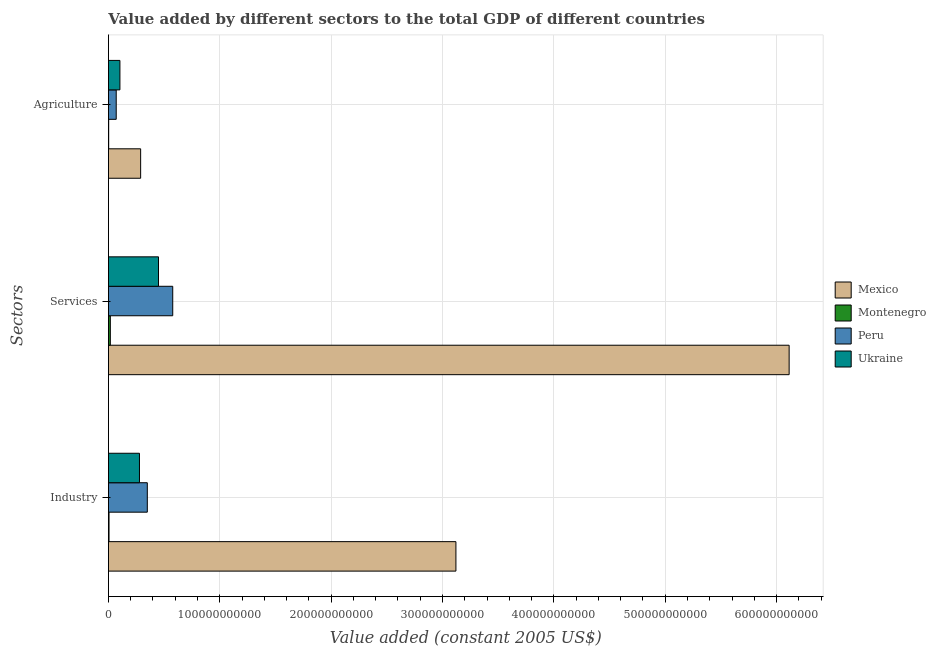How many different coloured bars are there?
Provide a succinct answer. 4. How many groups of bars are there?
Your response must be concise. 3. Are the number of bars per tick equal to the number of legend labels?
Provide a short and direct response. Yes. How many bars are there on the 3rd tick from the top?
Provide a short and direct response. 4. How many bars are there on the 2nd tick from the bottom?
Ensure brevity in your answer.  4. What is the label of the 1st group of bars from the top?
Give a very brief answer. Agriculture. What is the value added by industrial sector in Montenegro?
Your answer should be compact. 5.45e+08. Across all countries, what is the maximum value added by agricultural sector?
Give a very brief answer. 2.89e+1. Across all countries, what is the minimum value added by industrial sector?
Ensure brevity in your answer.  5.45e+08. In which country was the value added by services maximum?
Offer a terse response. Mexico. In which country was the value added by agricultural sector minimum?
Keep it short and to the point. Montenegro. What is the total value added by services in the graph?
Ensure brevity in your answer.  7.16e+11. What is the difference between the value added by industrial sector in Ukraine and that in Montenegro?
Provide a short and direct response. 2.73e+1. What is the difference between the value added by agricultural sector in Ukraine and the value added by industrial sector in Mexico?
Give a very brief answer. -3.02e+11. What is the average value added by agricultural sector per country?
Make the answer very short. 1.16e+1. What is the difference between the value added by services and value added by industrial sector in Mexico?
Offer a very short reply. 2.99e+11. In how many countries, is the value added by industrial sector greater than 120000000000 US$?
Offer a very short reply. 1. What is the ratio of the value added by services in Peru to that in Montenegro?
Give a very brief answer. 33.91. What is the difference between the highest and the second highest value added by agricultural sector?
Your answer should be very brief. 1.86e+1. What is the difference between the highest and the lowest value added by agricultural sector?
Your response must be concise. 2.87e+1. In how many countries, is the value added by agricultural sector greater than the average value added by agricultural sector taken over all countries?
Provide a succinct answer. 1. Is the sum of the value added by industrial sector in Montenegro and Mexico greater than the maximum value added by agricultural sector across all countries?
Your answer should be very brief. Yes. What does the 3rd bar from the top in Services represents?
Provide a short and direct response. Montenegro. What does the 2nd bar from the bottom in Agriculture represents?
Provide a succinct answer. Montenegro. How many countries are there in the graph?
Make the answer very short. 4. What is the difference between two consecutive major ticks on the X-axis?
Offer a terse response. 1.00e+11. Does the graph contain any zero values?
Provide a succinct answer. No. How are the legend labels stacked?
Provide a short and direct response. Vertical. What is the title of the graph?
Ensure brevity in your answer.  Value added by different sectors to the total GDP of different countries. Does "Antigua and Barbuda" appear as one of the legend labels in the graph?
Keep it short and to the point. No. What is the label or title of the X-axis?
Your answer should be compact. Value added (constant 2005 US$). What is the label or title of the Y-axis?
Ensure brevity in your answer.  Sectors. What is the Value added (constant 2005 US$) of Mexico in Industry?
Offer a very short reply. 3.12e+11. What is the Value added (constant 2005 US$) in Montenegro in Industry?
Provide a succinct answer. 5.45e+08. What is the Value added (constant 2005 US$) of Peru in Industry?
Your answer should be compact. 3.49e+1. What is the Value added (constant 2005 US$) in Ukraine in Industry?
Keep it short and to the point. 2.79e+1. What is the Value added (constant 2005 US$) in Mexico in Services?
Offer a very short reply. 6.11e+11. What is the Value added (constant 2005 US$) in Montenegro in Services?
Make the answer very short. 1.70e+09. What is the Value added (constant 2005 US$) in Peru in Services?
Your answer should be very brief. 5.77e+1. What is the Value added (constant 2005 US$) of Ukraine in Services?
Give a very brief answer. 4.50e+1. What is the Value added (constant 2005 US$) of Mexico in Agriculture?
Your answer should be very brief. 2.89e+1. What is the Value added (constant 2005 US$) of Montenegro in Agriculture?
Ensure brevity in your answer.  2.27e+08. What is the Value added (constant 2005 US$) of Peru in Agriculture?
Offer a very short reply. 6.99e+09. What is the Value added (constant 2005 US$) in Ukraine in Agriculture?
Keep it short and to the point. 1.03e+1. Across all Sectors, what is the maximum Value added (constant 2005 US$) in Mexico?
Make the answer very short. 6.11e+11. Across all Sectors, what is the maximum Value added (constant 2005 US$) in Montenegro?
Ensure brevity in your answer.  1.70e+09. Across all Sectors, what is the maximum Value added (constant 2005 US$) in Peru?
Ensure brevity in your answer.  5.77e+1. Across all Sectors, what is the maximum Value added (constant 2005 US$) of Ukraine?
Offer a terse response. 4.50e+1. Across all Sectors, what is the minimum Value added (constant 2005 US$) in Mexico?
Your answer should be very brief. 2.89e+1. Across all Sectors, what is the minimum Value added (constant 2005 US$) of Montenegro?
Offer a terse response. 2.27e+08. Across all Sectors, what is the minimum Value added (constant 2005 US$) in Peru?
Offer a terse response. 6.99e+09. Across all Sectors, what is the minimum Value added (constant 2005 US$) of Ukraine?
Your answer should be compact. 1.03e+1. What is the total Value added (constant 2005 US$) in Mexico in the graph?
Offer a terse response. 9.52e+11. What is the total Value added (constant 2005 US$) in Montenegro in the graph?
Keep it short and to the point. 2.47e+09. What is the total Value added (constant 2005 US$) of Peru in the graph?
Make the answer very short. 9.97e+1. What is the total Value added (constant 2005 US$) in Ukraine in the graph?
Make the answer very short. 8.31e+1. What is the difference between the Value added (constant 2005 US$) of Mexico in Industry and that in Services?
Your answer should be compact. -2.99e+11. What is the difference between the Value added (constant 2005 US$) in Montenegro in Industry and that in Services?
Your answer should be compact. -1.16e+09. What is the difference between the Value added (constant 2005 US$) in Peru in Industry and that in Services?
Ensure brevity in your answer.  -2.28e+1. What is the difference between the Value added (constant 2005 US$) in Ukraine in Industry and that in Services?
Offer a very short reply. -1.71e+1. What is the difference between the Value added (constant 2005 US$) in Mexico in Industry and that in Agriculture?
Give a very brief answer. 2.83e+11. What is the difference between the Value added (constant 2005 US$) in Montenegro in Industry and that in Agriculture?
Offer a terse response. 3.18e+08. What is the difference between the Value added (constant 2005 US$) of Peru in Industry and that in Agriculture?
Your answer should be very brief. 2.79e+1. What is the difference between the Value added (constant 2005 US$) of Ukraine in Industry and that in Agriculture?
Provide a short and direct response. 1.76e+1. What is the difference between the Value added (constant 2005 US$) of Mexico in Services and that in Agriculture?
Keep it short and to the point. 5.82e+11. What is the difference between the Value added (constant 2005 US$) in Montenegro in Services and that in Agriculture?
Provide a succinct answer. 1.48e+09. What is the difference between the Value added (constant 2005 US$) of Peru in Services and that in Agriculture?
Make the answer very short. 5.08e+1. What is the difference between the Value added (constant 2005 US$) in Ukraine in Services and that in Agriculture?
Your response must be concise. 3.46e+1. What is the difference between the Value added (constant 2005 US$) of Mexico in Industry and the Value added (constant 2005 US$) of Montenegro in Services?
Offer a very short reply. 3.10e+11. What is the difference between the Value added (constant 2005 US$) in Mexico in Industry and the Value added (constant 2005 US$) in Peru in Services?
Provide a succinct answer. 2.54e+11. What is the difference between the Value added (constant 2005 US$) of Mexico in Industry and the Value added (constant 2005 US$) of Ukraine in Services?
Your response must be concise. 2.67e+11. What is the difference between the Value added (constant 2005 US$) in Montenegro in Industry and the Value added (constant 2005 US$) in Peru in Services?
Provide a succinct answer. -5.72e+1. What is the difference between the Value added (constant 2005 US$) in Montenegro in Industry and the Value added (constant 2005 US$) in Ukraine in Services?
Your answer should be compact. -4.44e+1. What is the difference between the Value added (constant 2005 US$) in Peru in Industry and the Value added (constant 2005 US$) in Ukraine in Services?
Your answer should be very brief. -1.00e+1. What is the difference between the Value added (constant 2005 US$) in Mexico in Industry and the Value added (constant 2005 US$) in Montenegro in Agriculture?
Give a very brief answer. 3.12e+11. What is the difference between the Value added (constant 2005 US$) in Mexico in Industry and the Value added (constant 2005 US$) in Peru in Agriculture?
Ensure brevity in your answer.  3.05e+11. What is the difference between the Value added (constant 2005 US$) of Mexico in Industry and the Value added (constant 2005 US$) of Ukraine in Agriculture?
Make the answer very short. 3.02e+11. What is the difference between the Value added (constant 2005 US$) of Montenegro in Industry and the Value added (constant 2005 US$) of Peru in Agriculture?
Make the answer very short. -6.45e+09. What is the difference between the Value added (constant 2005 US$) in Montenegro in Industry and the Value added (constant 2005 US$) in Ukraine in Agriculture?
Your answer should be compact. -9.77e+09. What is the difference between the Value added (constant 2005 US$) in Peru in Industry and the Value added (constant 2005 US$) in Ukraine in Agriculture?
Ensure brevity in your answer.  2.46e+1. What is the difference between the Value added (constant 2005 US$) in Mexico in Services and the Value added (constant 2005 US$) in Montenegro in Agriculture?
Offer a very short reply. 6.11e+11. What is the difference between the Value added (constant 2005 US$) in Mexico in Services and the Value added (constant 2005 US$) in Peru in Agriculture?
Offer a terse response. 6.04e+11. What is the difference between the Value added (constant 2005 US$) in Mexico in Services and the Value added (constant 2005 US$) in Ukraine in Agriculture?
Make the answer very short. 6.01e+11. What is the difference between the Value added (constant 2005 US$) of Montenegro in Services and the Value added (constant 2005 US$) of Peru in Agriculture?
Offer a very short reply. -5.29e+09. What is the difference between the Value added (constant 2005 US$) in Montenegro in Services and the Value added (constant 2005 US$) in Ukraine in Agriculture?
Your answer should be compact. -8.61e+09. What is the difference between the Value added (constant 2005 US$) of Peru in Services and the Value added (constant 2005 US$) of Ukraine in Agriculture?
Provide a short and direct response. 4.74e+1. What is the average Value added (constant 2005 US$) in Mexico per Sectors?
Offer a very short reply. 3.17e+11. What is the average Value added (constant 2005 US$) in Montenegro per Sectors?
Ensure brevity in your answer.  8.25e+08. What is the average Value added (constant 2005 US$) in Peru per Sectors?
Provide a succinct answer. 3.32e+1. What is the average Value added (constant 2005 US$) of Ukraine per Sectors?
Your answer should be compact. 2.77e+1. What is the difference between the Value added (constant 2005 US$) in Mexico and Value added (constant 2005 US$) in Montenegro in Industry?
Your answer should be compact. 3.12e+11. What is the difference between the Value added (constant 2005 US$) in Mexico and Value added (constant 2005 US$) in Peru in Industry?
Provide a short and direct response. 2.77e+11. What is the difference between the Value added (constant 2005 US$) in Mexico and Value added (constant 2005 US$) in Ukraine in Industry?
Make the answer very short. 2.84e+11. What is the difference between the Value added (constant 2005 US$) of Montenegro and Value added (constant 2005 US$) of Peru in Industry?
Provide a succinct answer. -3.44e+1. What is the difference between the Value added (constant 2005 US$) in Montenegro and Value added (constant 2005 US$) in Ukraine in Industry?
Keep it short and to the point. -2.73e+1. What is the difference between the Value added (constant 2005 US$) of Peru and Value added (constant 2005 US$) of Ukraine in Industry?
Provide a succinct answer. 7.05e+09. What is the difference between the Value added (constant 2005 US$) in Mexico and Value added (constant 2005 US$) in Montenegro in Services?
Offer a terse response. 6.10e+11. What is the difference between the Value added (constant 2005 US$) of Mexico and Value added (constant 2005 US$) of Peru in Services?
Ensure brevity in your answer.  5.54e+11. What is the difference between the Value added (constant 2005 US$) in Mexico and Value added (constant 2005 US$) in Ukraine in Services?
Your answer should be compact. 5.66e+11. What is the difference between the Value added (constant 2005 US$) of Montenegro and Value added (constant 2005 US$) of Peru in Services?
Give a very brief answer. -5.60e+1. What is the difference between the Value added (constant 2005 US$) in Montenegro and Value added (constant 2005 US$) in Ukraine in Services?
Ensure brevity in your answer.  -4.33e+1. What is the difference between the Value added (constant 2005 US$) of Peru and Value added (constant 2005 US$) of Ukraine in Services?
Offer a terse response. 1.28e+1. What is the difference between the Value added (constant 2005 US$) in Mexico and Value added (constant 2005 US$) in Montenegro in Agriculture?
Your answer should be compact. 2.87e+1. What is the difference between the Value added (constant 2005 US$) in Mexico and Value added (constant 2005 US$) in Peru in Agriculture?
Keep it short and to the point. 2.19e+1. What is the difference between the Value added (constant 2005 US$) of Mexico and Value added (constant 2005 US$) of Ukraine in Agriculture?
Your answer should be compact. 1.86e+1. What is the difference between the Value added (constant 2005 US$) of Montenegro and Value added (constant 2005 US$) of Peru in Agriculture?
Provide a short and direct response. -6.77e+09. What is the difference between the Value added (constant 2005 US$) in Montenegro and Value added (constant 2005 US$) in Ukraine in Agriculture?
Give a very brief answer. -1.01e+1. What is the difference between the Value added (constant 2005 US$) of Peru and Value added (constant 2005 US$) of Ukraine in Agriculture?
Provide a short and direct response. -3.32e+09. What is the ratio of the Value added (constant 2005 US$) in Mexico in Industry to that in Services?
Offer a terse response. 0.51. What is the ratio of the Value added (constant 2005 US$) of Montenegro in Industry to that in Services?
Your answer should be very brief. 0.32. What is the ratio of the Value added (constant 2005 US$) of Peru in Industry to that in Services?
Make the answer very short. 0.6. What is the ratio of the Value added (constant 2005 US$) in Ukraine in Industry to that in Services?
Provide a succinct answer. 0.62. What is the ratio of the Value added (constant 2005 US$) of Mexico in Industry to that in Agriculture?
Give a very brief answer. 10.79. What is the ratio of the Value added (constant 2005 US$) of Montenegro in Industry to that in Agriculture?
Your response must be concise. 2.4. What is the ratio of the Value added (constant 2005 US$) in Peru in Industry to that in Agriculture?
Offer a terse response. 4.99. What is the ratio of the Value added (constant 2005 US$) of Ukraine in Industry to that in Agriculture?
Ensure brevity in your answer.  2.7. What is the ratio of the Value added (constant 2005 US$) of Mexico in Services to that in Agriculture?
Your answer should be very brief. 21.14. What is the ratio of the Value added (constant 2005 US$) of Montenegro in Services to that in Agriculture?
Provide a short and direct response. 7.5. What is the ratio of the Value added (constant 2005 US$) in Peru in Services to that in Agriculture?
Ensure brevity in your answer.  8.26. What is the ratio of the Value added (constant 2005 US$) in Ukraine in Services to that in Agriculture?
Keep it short and to the point. 4.36. What is the difference between the highest and the second highest Value added (constant 2005 US$) of Mexico?
Your answer should be very brief. 2.99e+11. What is the difference between the highest and the second highest Value added (constant 2005 US$) of Montenegro?
Provide a short and direct response. 1.16e+09. What is the difference between the highest and the second highest Value added (constant 2005 US$) of Peru?
Offer a terse response. 2.28e+1. What is the difference between the highest and the second highest Value added (constant 2005 US$) in Ukraine?
Make the answer very short. 1.71e+1. What is the difference between the highest and the lowest Value added (constant 2005 US$) in Mexico?
Ensure brevity in your answer.  5.82e+11. What is the difference between the highest and the lowest Value added (constant 2005 US$) in Montenegro?
Make the answer very short. 1.48e+09. What is the difference between the highest and the lowest Value added (constant 2005 US$) of Peru?
Offer a very short reply. 5.08e+1. What is the difference between the highest and the lowest Value added (constant 2005 US$) of Ukraine?
Ensure brevity in your answer.  3.46e+1. 